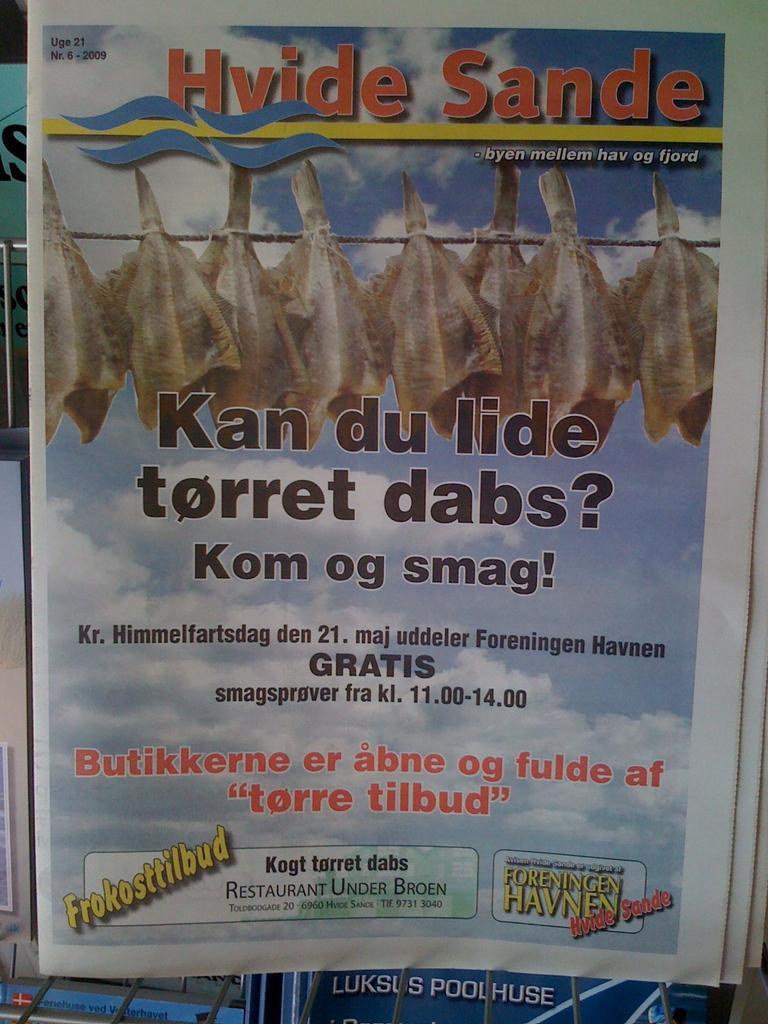How would you summarize this image in a sentence or two? In this image I can see a paper in the metal stand and on the paper I can see few objects tied to the ropes, the sky and something is written on the paper. 